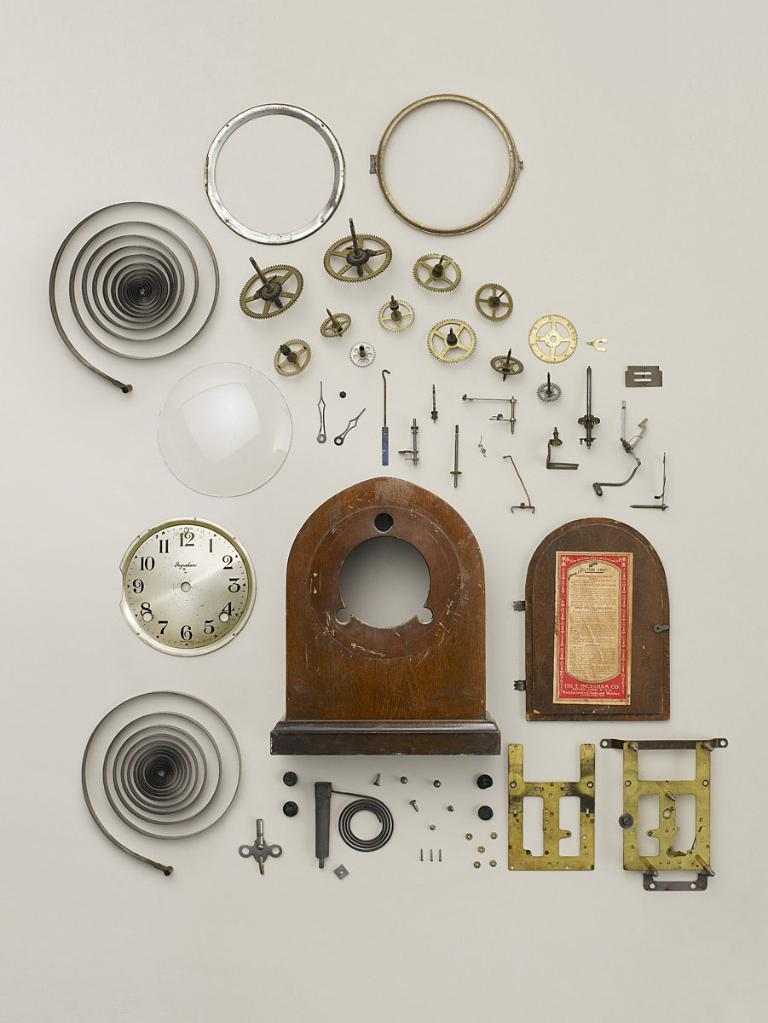What objects are related to a clock in the image? There are spare parts of a clock in the image. What color is the background of the image? The background of the image is white. What type of library is shown in the image? There is no library present in the image; it features spare parts of a clock against a white background. What emotion is being expressed by the spare parts of the clock in the image? The spare parts of the clock are inanimate objects and do not express emotions like hate. 